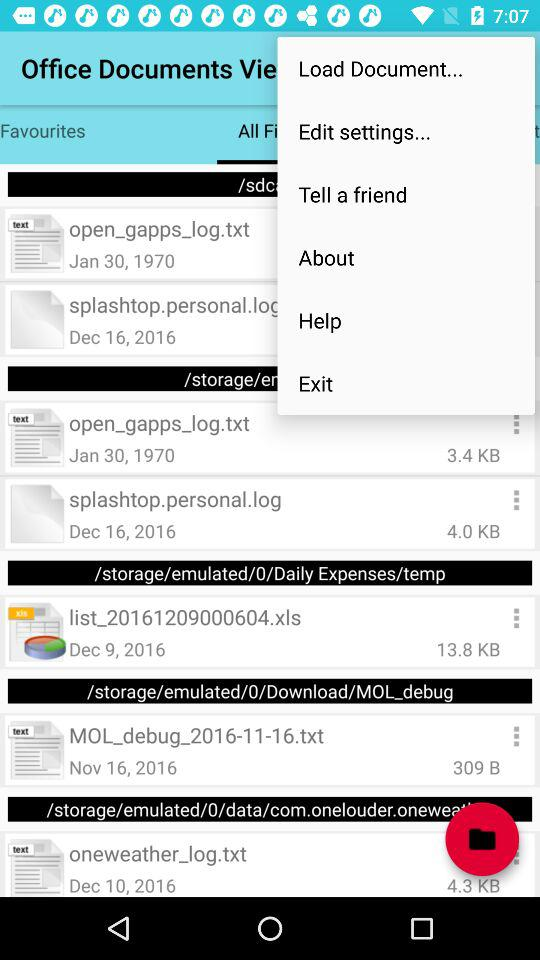What is the storage size of the file "splashtop.personal.log"? The storage size of the file "splashtop.personal.log" is 4.0 KB. 